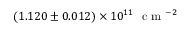<formula> <loc_0><loc_0><loc_500><loc_500>( 1 . 1 2 0 \pm 0 . 0 1 2 ) \times 1 0 ^ { 1 1 } c m ^ { - 2 }</formula> 